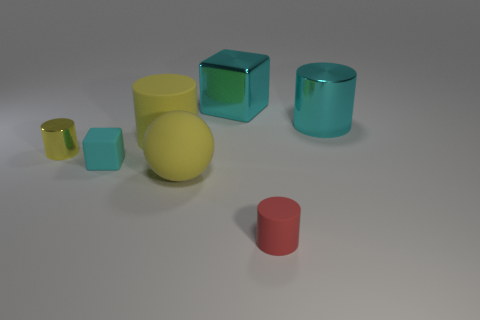Add 2 cyan blocks. How many objects exist? 9 Subtract all cylinders. How many objects are left? 3 Add 5 cyan metallic objects. How many cyan metallic objects exist? 7 Subtract 0 green spheres. How many objects are left? 7 Subtract all big matte objects. Subtract all tiny yellow shiny things. How many objects are left? 4 Add 5 tiny red rubber objects. How many tiny red rubber objects are left? 6 